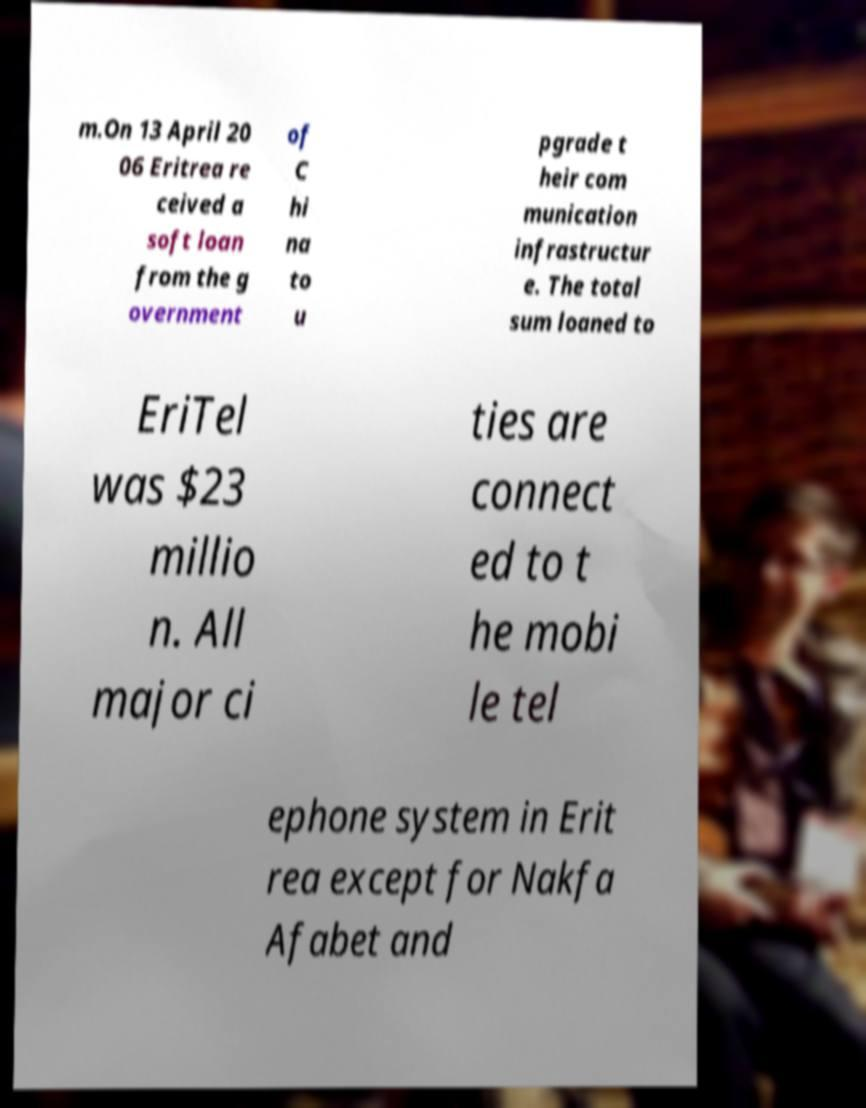Could you extract and type out the text from this image? m.On 13 April 20 06 Eritrea re ceived a soft loan from the g overnment of C hi na to u pgrade t heir com munication infrastructur e. The total sum loaned to EriTel was $23 millio n. All major ci ties are connect ed to t he mobi le tel ephone system in Erit rea except for Nakfa Afabet and 